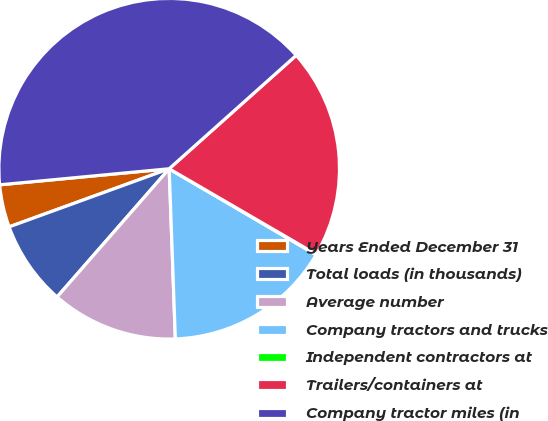Convert chart. <chart><loc_0><loc_0><loc_500><loc_500><pie_chart><fcel>Years Ended December 31<fcel>Total loads (in thousands)<fcel>Average number<fcel>Company tractors and trucks<fcel>Independent contractors at<fcel>Trailers/containers at<fcel>Company tractor miles (in<nl><fcel>4.04%<fcel>8.02%<fcel>12.01%<fcel>15.99%<fcel>0.05%<fcel>19.98%<fcel>39.9%<nl></chart> 